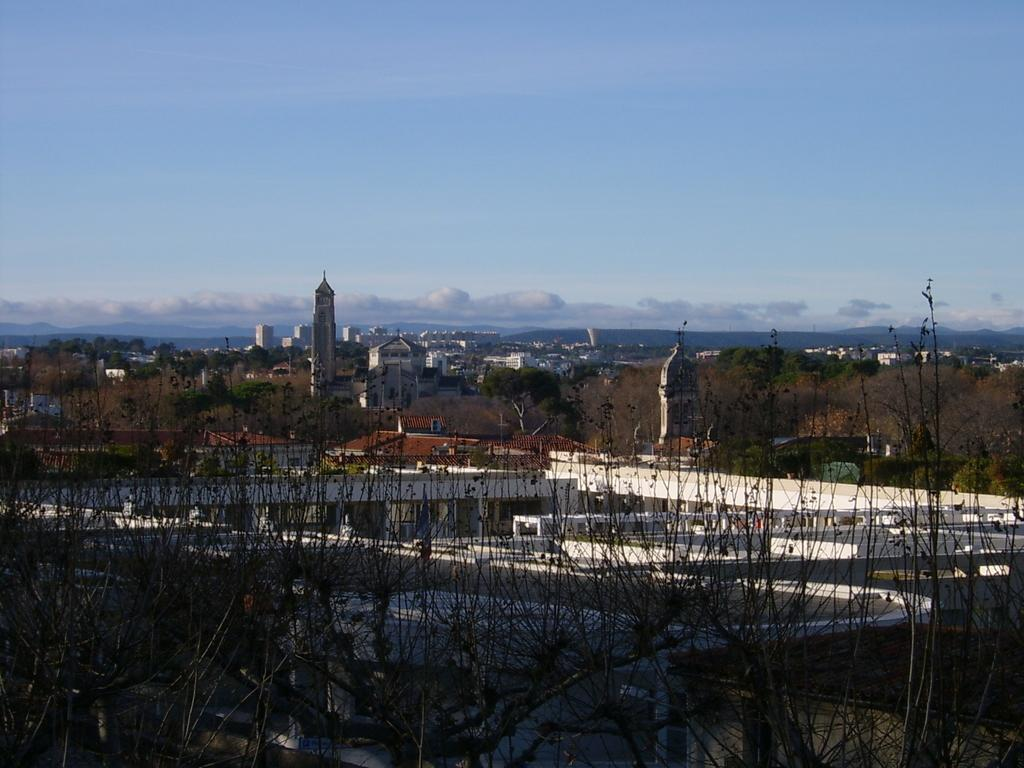What type of natural elements can be seen in the image? There are trees in the image. What type of man-made structures are present in the image? There are buildings in the image. What part of the natural environment is visible in the image? The sky is visible in the background of the image. How would you describe the weather based on the appearance of the sky? The sky appears to be cloudy in the image. How many tubes of toothpaste are hanging from the trees in the image? There are no tubes of toothpaste present in the image; it features trees, buildings, and a cloudy sky. What type of reaction can be observed between the lizards and the buildings in the image? There are no lizards present in the image, so no such reaction can be observed. 